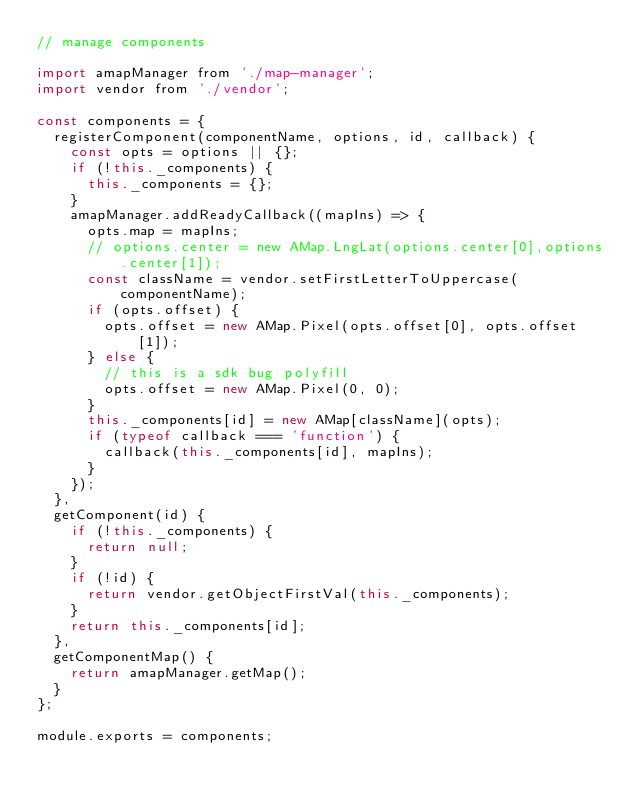<code> <loc_0><loc_0><loc_500><loc_500><_JavaScript_>// manage components

import amapManager from './map-manager';
import vendor from './vendor';

const components = {
  registerComponent(componentName, options, id, callback) {
    const opts = options || {};
    if (!this._components) {
      this._components = {};
    }
    amapManager.addReadyCallback((mapIns) => {
      opts.map = mapIns;
      // options.center = new AMap.LngLat(options.center[0],options.center[1]);
      const className = vendor.setFirstLetterToUppercase(componentName);
      if (opts.offset) {
        opts.offset = new AMap.Pixel(opts.offset[0], opts.offset[1]);
      } else {
        // this is a sdk bug polyfill
        opts.offset = new AMap.Pixel(0, 0);
      }
      this._components[id] = new AMap[className](opts);
      if (typeof callback === 'function') {
        callback(this._components[id], mapIns);
      }
    });
  },
  getComponent(id) {
    if (!this._components) {
      return null;
    }
    if (!id) {
      return vendor.getObjectFirstVal(this._components);
    }
    return this._components[id];
  },
  getComponentMap() {
    return amapManager.getMap();
  }
};

module.exports = components;
</code> 